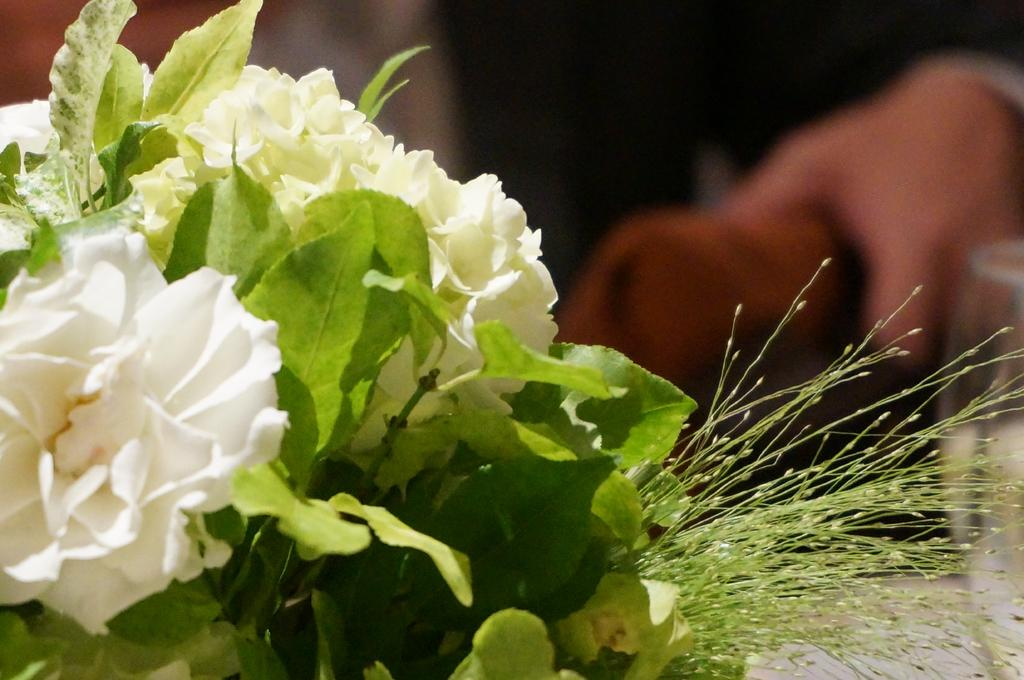What type of plant life is visible in the image? There are leaves and flowers in the image. Can you describe the background of the image? The background of the image is blurred. Where is the cactus located in the image? There is no cactus present in the image. What thought is being expressed by the flowers in the image? The flowers in the image are not expressing any thoughts, as they are inanimate objects. 